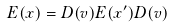Convert formula to latex. <formula><loc_0><loc_0><loc_500><loc_500>E ( x ) = D ( v ) E ( x ^ { \prime } ) D ( v )</formula> 